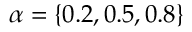Convert formula to latex. <formula><loc_0><loc_0><loc_500><loc_500>\alpha = \{ 0 . 2 , 0 . 5 , 0 . 8 \}</formula> 